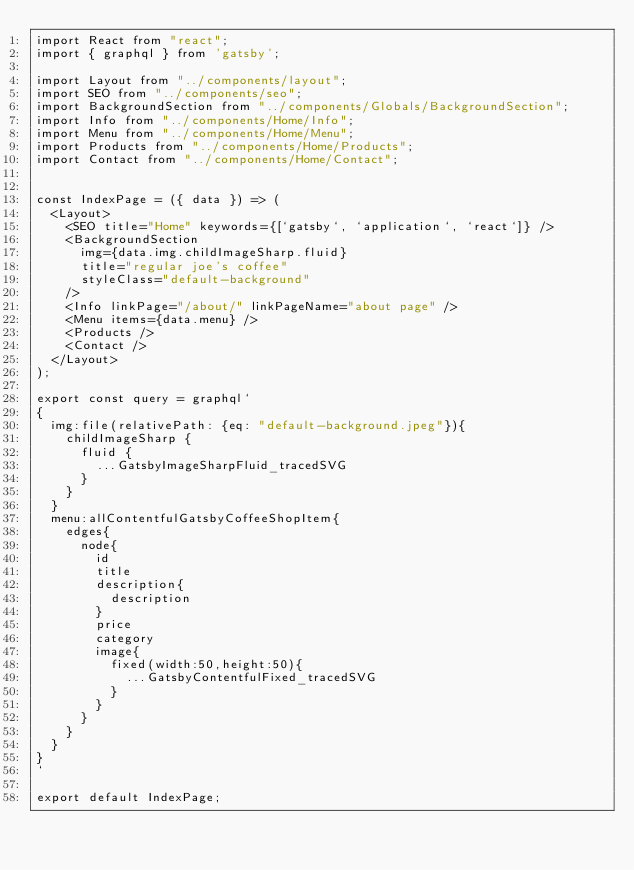Convert code to text. <code><loc_0><loc_0><loc_500><loc_500><_JavaScript_>import React from "react";
import { graphql } from 'gatsby';

import Layout from "../components/layout";
import SEO from "../components/seo";
import BackgroundSection from "../components/Globals/BackgroundSection";
import Info from "../components/Home/Info";
import Menu from "../components/Home/Menu";
import Products from "../components/Home/Products";
import Contact from "../components/Home/Contact";


const IndexPage = ({ data }) => (
  <Layout>
    <SEO title="Home" keywords={[`gatsby`, `application`, `react`]} />
    <BackgroundSection
      img={data.img.childImageSharp.fluid}
      title="regular joe's coffee"
      styleClass="default-background"
    />
    <Info linkPage="/about/" linkPageName="about page" />
    <Menu items={data.menu} />
    <Products />
    <Contact />
  </Layout>
);

export const query = graphql`
{
  img:file(relativePath: {eq: "default-background.jpeg"}){
    childImageSharp {
      fluid {
        ...GatsbyImageSharpFluid_tracedSVG
      }
    }
  }
  menu:allContentfulGatsbyCoffeeShopItem{
    edges{
      node{
        id
        title
        description{
          description
        }
        price
        category
        image{
          fixed(width:50,height:50){
            ...GatsbyContentfulFixed_tracedSVG
          }
        }
      }
    }
  }
}
`

export default IndexPage;
</code> 